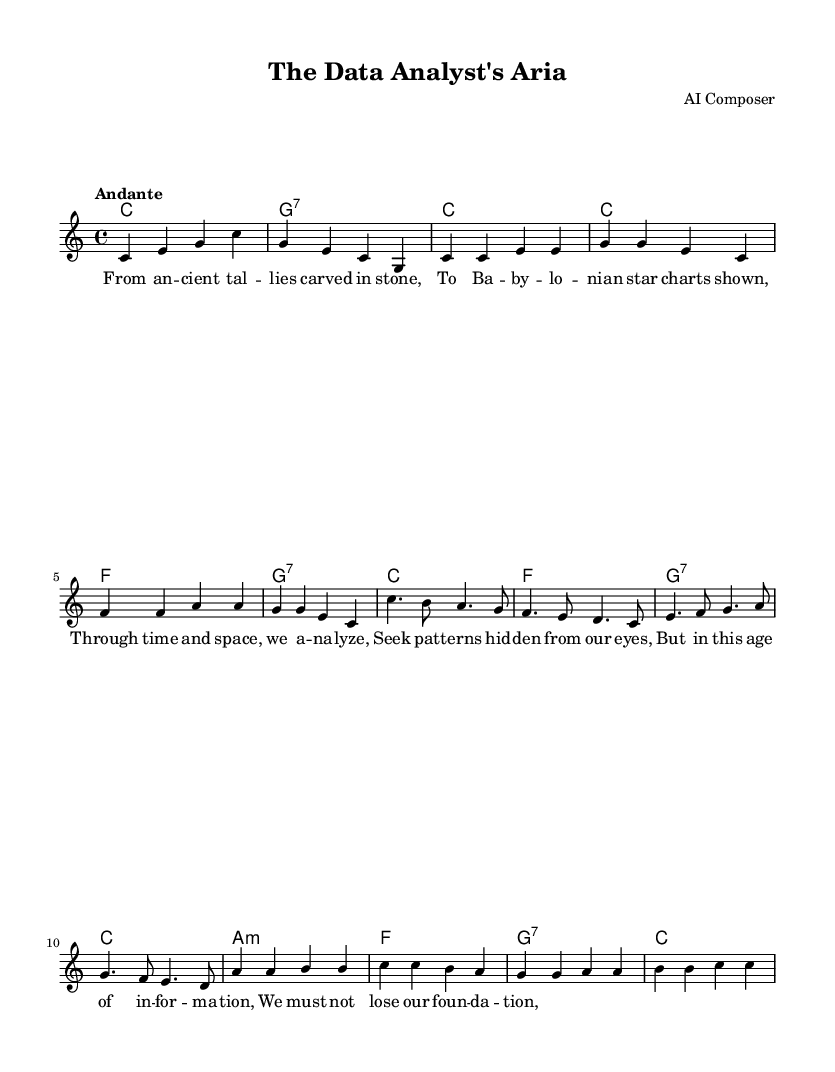What is the key signature of this music? The key signature is C major, which has no sharps or flats.
Answer: C major What is the time signature of the piece? The time signature indicated is 4/4, meaning there are four beats in each measure.
Answer: 4/4 What is the tempo marking of this music? The tempo marking specified is "Andante," which indicates a moderately slow tempo.
Answer: Andante How many measures are in the chorus section? The chorus section consists of four measures, as seen in the grouping of notes and notation in that part of the music.
Answer: 4 What chord is played during the first measure? The first measure contains a C major chord, as indicated by the chord name above the staff.
Answer: C Which refrain section features a descending melodic line? The bridge section features a descending melodic line, particularly noticeable in the notes that move downward from c to b to a.
Answer: Bridge What philosophical theme is explored in the lyrics? The lyrics explore the theme of analyzing patterns through time and information, highlighting the importance of foundational knowledge in data analysis.
Answer: Analysis of patterns 